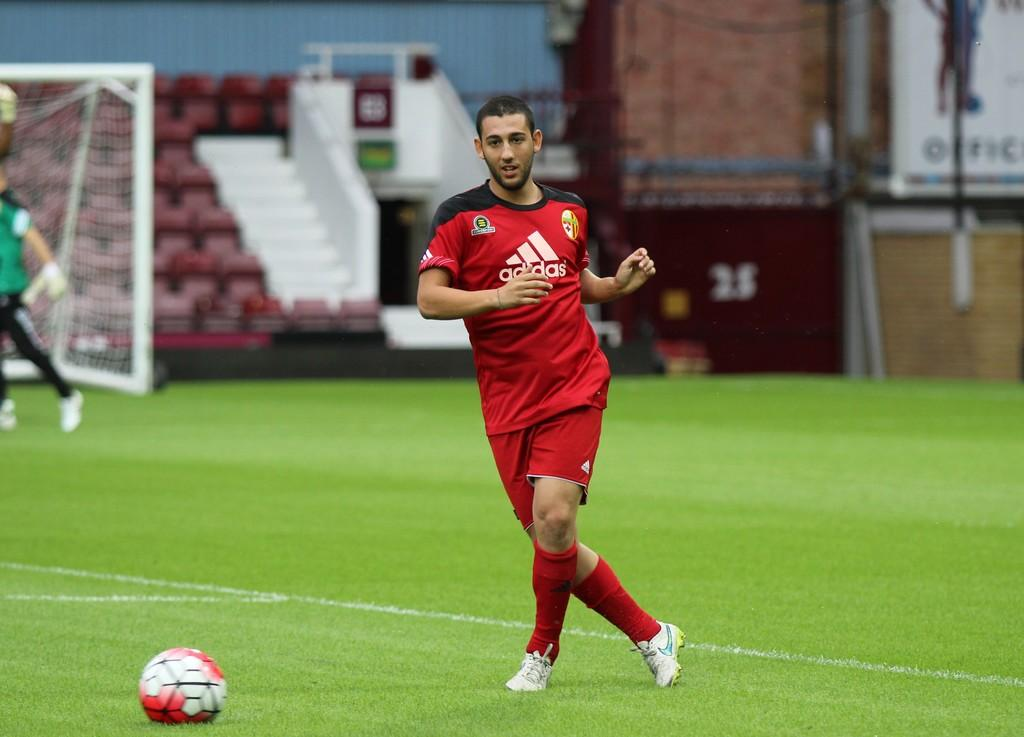Who is the main subject in the image? There is a boy in the image. What is the boy wearing? The boy is wearing a red t-shirt and shorts. What activity is the boy engaged in? The boy is playing football. Where is the boy playing football? There is a football ground in the image. What can be seen near the football ground? There is a white-colored goal post in the image. What type of seating is visible in the image? There are stadium seats visible in the image. What is the boy's role as a representative in the image? There is no indication in the image that the boy is a representative or has any specific role. 